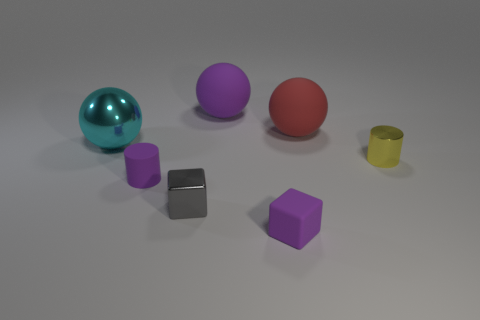Subtract all matte spheres. How many spheres are left? 1 Add 2 red shiny objects. How many objects exist? 9 Add 3 tiny gray shiny things. How many tiny gray shiny things are left? 4 Add 7 tiny red matte things. How many tiny red matte things exist? 7 Subtract 0 brown spheres. How many objects are left? 7 Subtract all balls. How many objects are left? 4 Subtract all large brown matte objects. Subtract all big purple rubber balls. How many objects are left? 6 